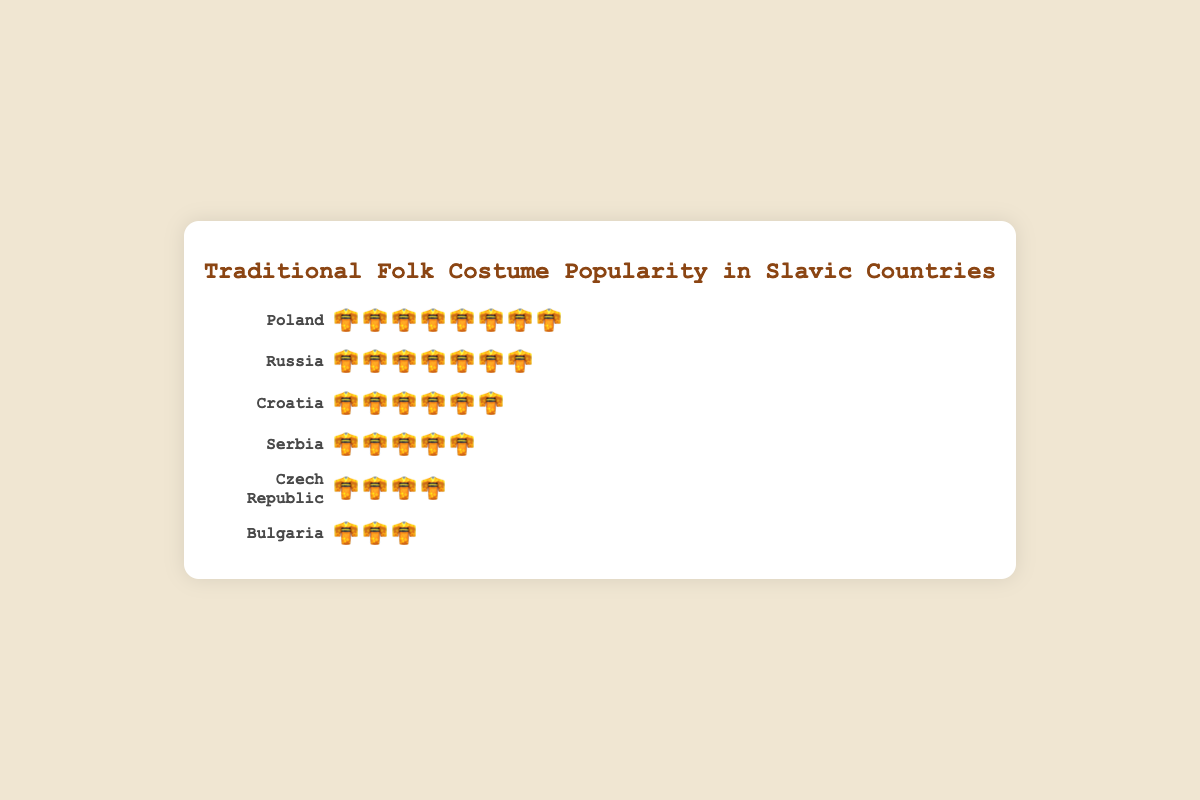What's the title of the chart? The title is found at the top of the chart, centered and styled to stand out from the rest of the text.
Answer: Traditional Folk Costume Popularity in Slavic Countries Which country has the highest costume popularity? By scanning the countries listed along with the corresponding icons, Poland has the most icons, indicating the highest popularity.
Answer: Poland How much more popular are traditional folk costumes in Poland compared to Bulgaria? Poland has 8 icons and Bulgaria has 3 icons. The difference in popularity is calculated by subtracting Bulgaria's count from Poland's count (8 - 3).
Answer: 5 Which country has less costume popularity, Russia or Serbia? Russia has 7 icons while Serbia has 5 icons. Therefore, Serbia has less costume popularity.
Answer: Serbia What's the total count of icons representing costume popularity across all countries? Sum the number of icons for each country: Poland (8) + Russia (7) + Croatia (6) + Serbia (5) + Czech Republic (4) + Bulgaria (3) = 33.
Answer: 33 Is the costume popularity in Croatia higher, lower, or the same compared to the Czech Republic and Bulgaria combined? Croatia has 6 icons. The Czech Republic has 4 icons, and Bulgaria has 3 icons. Combined, Czech Republic and Bulgaria have 4 + 3 = 7 icons, which is higher than Croatia's 6 icons.
Answer: Lower Rank the countries from the one with the most costume popularity to the one with the least. By comparing the number of icons visually, the ranking from most to least is: Poland (8), Russia (7), Croatia (6), Serbia (5), Czech Republic (4), Bulgaria (3).
Answer: Poland, Russia, Croatia, Serbia, Czech Republic, Bulgaria How many more countries have icon counts in the range of 5 to 8 compared to 1 to 4? The countries with icon counts of 5 to 8 are Poland (8), Russia (7), Croatia (6), and Serbia (5) — 4 in total. The countries with icon counts of 1 to 4 are Czech Republic (4) and Bulgaria (3) — 2 in total. The difference is 4 - 2.
Answer: 2 How does the costume popularity of Serbia compare to the average costume popularity of all countries? The total count of icons is 33. There are 6 countries. The average is 33 / 6 = 5.5. Serbia has 5 icons, which is 5, so Serbia's popularity is slightly below average.
Answer: Slightly below average Which country is exactly in the middle when you rank them by costume popularity? When the countries are ranked in order: Poland (8), Russia (7), Croatia (6), Serbia (5), Czech Republic (4), Bulgaria (3). Serbia and Czech Republic are in the middle positions, with Serbia having higher popularity.
Answer: Serbia 